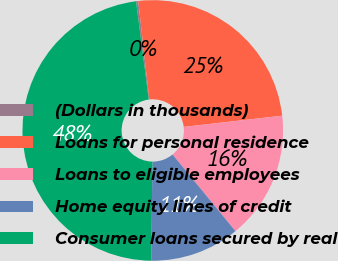Convert chart to OTSL. <chart><loc_0><loc_0><loc_500><loc_500><pie_chart><fcel>(Dollars in thousands)<fcel>Loans for personal residence<fcel>Loans to eligible employees<fcel>Home equity lines of credit<fcel>Consumer loans secured by real<nl><fcel>0.27%<fcel>24.97%<fcel>15.87%<fcel>11.12%<fcel>47.78%<nl></chart> 